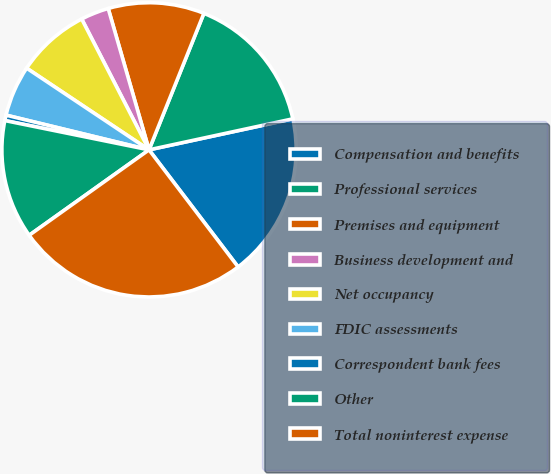<chart> <loc_0><loc_0><loc_500><loc_500><pie_chart><fcel>Compensation and benefits<fcel>Professional services<fcel>Premises and equipment<fcel>Business development and<fcel>Net occupancy<fcel>FDIC assessments<fcel>Correspondent bank fees<fcel>Other<fcel>Total noninterest expense<nl><fcel>18.03%<fcel>15.54%<fcel>10.56%<fcel>3.09%<fcel>8.07%<fcel>5.58%<fcel>0.6%<fcel>13.05%<fcel>25.5%<nl></chart> 